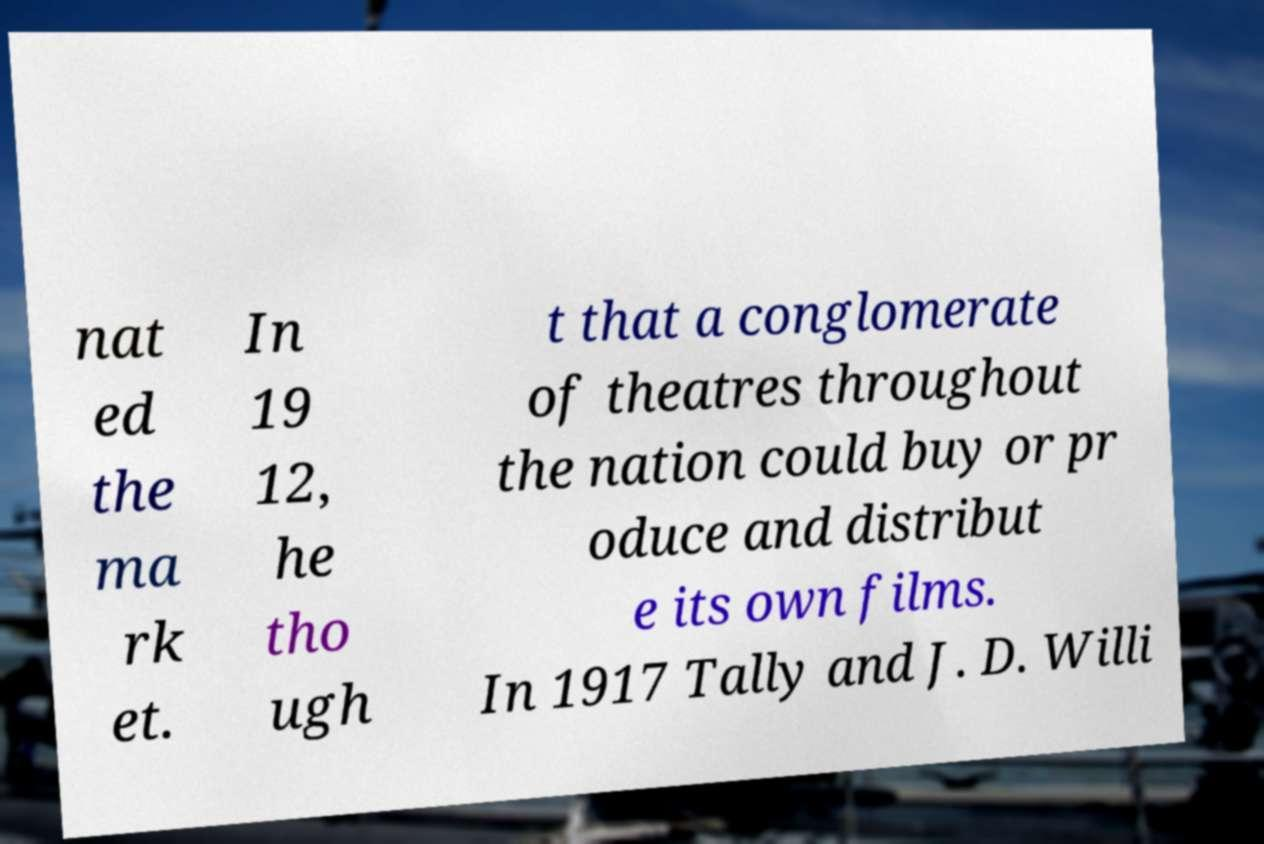Can you read and provide the text displayed in the image?This photo seems to have some interesting text. Can you extract and type it out for me? nat ed the ma rk et. In 19 12, he tho ugh t that a conglomerate of theatres throughout the nation could buy or pr oduce and distribut e its own films. In 1917 Tally and J. D. Willi 